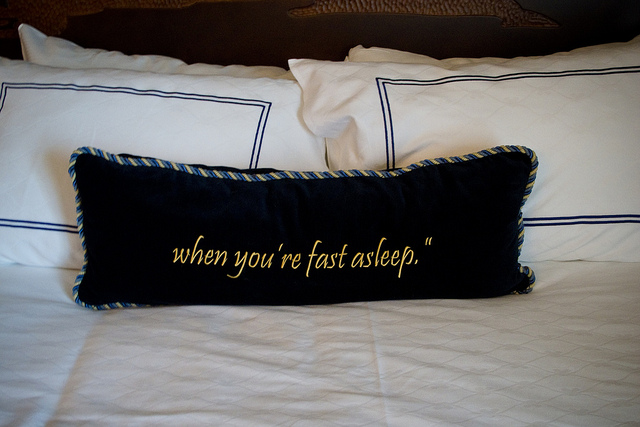Identify the text contained in this image. when you ' re fast asleep." 